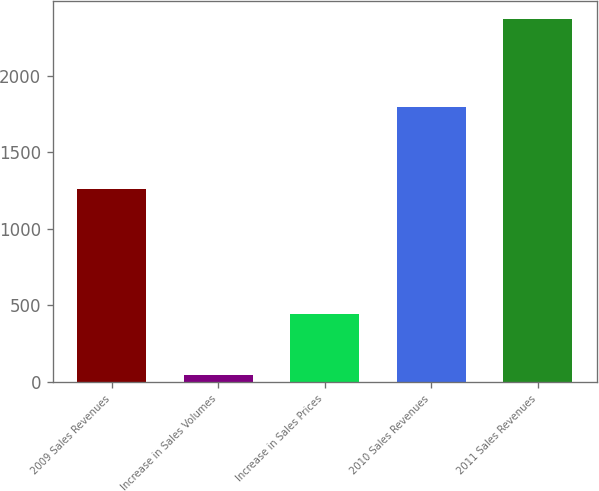<chart> <loc_0><loc_0><loc_500><loc_500><bar_chart><fcel>2009 Sales Revenues<fcel>Increase in Sales Volumes<fcel>Increase in Sales Prices<fcel>2010 Sales Revenues<fcel>2011 Sales Revenues<nl><fcel>1261<fcel>48<fcel>447<fcel>1795<fcel>2373<nl></chart> 